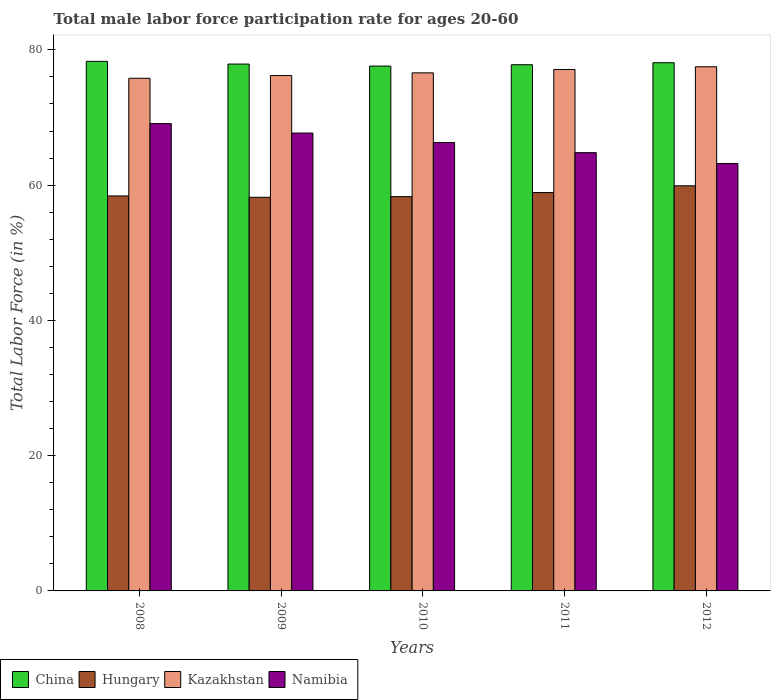How many groups of bars are there?
Your answer should be very brief. 5. Are the number of bars per tick equal to the number of legend labels?
Provide a succinct answer. Yes. How many bars are there on the 1st tick from the left?
Provide a succinct answer. 4. How many bars are there on the 4th tick from the right?
Give a very brief answer. 4. What is the label of the 4th group of bars from the left?
Give a very brief answer. 2011. What is the male labor force participation rate in China in 2011?
Ensure brevity in your answer.  77.8. Across all years, what is the maximum male labor force participation rate in Namibia?
Ensure brevity in your answer.  69.1. Across all years, what is the minimum male labor force participation rate in Namibia?
Ensure brevity in your answer.  63.2. In which year was the male labor force participation rate in Kazakhstan maximum?
Offer a terse response. 2012. In which year was the male labor force participation rate in Hungary minimum?
Offer a terse response. 2009. What is the total male labor force participation rate in China in the graph?
Offer a terse response. 389.7. What is the difference between the male labor force participation rate in Namibia in 2010 and that in 2012?
Provide a short and direct response. 3.1. What is the difference between the male labor force participation rate in China in 2010 and the male labor force participation rate in Kazakhstan in 2009?
Your response must be concise. 1.4. What is the average male labor force participation rate in Hungary per year?
Your answer should be compact. 58.74. In the year 2011, what is the difference between the male labor force participation rate in Kazakhstan and male labor force participation rate in Namibia?
Provide a succinct answer. 12.3. What is the ratio of the male labor force participation rate in Kazakhstan in 2009 to that in 2012?
Your response must be concise. 0.98. Is the male labor force participation rate in Namibia in 2011 less than that in 2012?
Offer a terse response. No. What is the difference between the highest and the second highest male labor force participation rate in Kazakhstan?
Offer a terse response. 0.4. What is the difference between the highest and the lowest male labor force participation rate in Kazakhstan?
Give a very brief answer. 1.7. In how many years, is the male labor force participation rate in Kazakhstan greater than the average male labor force participation rate in Kazakhstan taken over all years?
Your response must be concise. 2. What does the 1st bar from the left in 2010 represents?
Make the answer very short. China. What does the 3rd bar from the right in 2008 represents?
Provide a succinct answer. Hungary. Is it the case that in every year, the sum of the male labor force participation rate in China and male labor force participation rate in Namibia is greater than the male labor force participation rate in Kazakhstan?
Keep it short and to the point. Yes. How many bars are there?
Provide a short and direct response. 20. What is the difference between two consecutive major ticks on the Y-axis?
Give a very brief answer. 20. Are the values on the major ticks of Y-axis written in scientific E-notation?
Offer a very short reply. No. What is the title of the graph?
Your answer should be very brief. Total male labor force participation rate for ages 20-60. What is the Total Labor Force (in %) of China in 2008?
Ensure brevity in your answer.  78.3. What is the Total Labor Force (in %) of Hungary in 2008?
Your answer should be very brief. 58.4. What is the Total Labor Force (in %) of Kazakhstan in 2008?
Your response must be concise. 75.8. What is the Total Labor Force (in %) in Namibia in 2008?
Your answer should be compact. 69.1. What is the Total Labor Force (in %) in China in 2009?
Offer a terse response. 77.9. What is the Total Labor Force (in %) of Hungary in 2009?
Your response must be concise. 58.2. What is the Total Labor Force (in %) of Kazakhstan in 2009?
Offer a terse response. 76.2. What is the Total Labor Force (in %) of Namibia in 2009?
Provide a succinct answer. 67.7. What is the Total Labor Force (in %) of China in 2010?
Ensure brevity in your answer.  77.6. What is the Total Labor Force (in %) of Hungary in 2010?
Give a very brief answer. 58.3. What is the Total Labor Force (in %) of Kazakhstan in 2010?
Make the answer very short. 76.6. What is the Total Labor Force (in %) in Namibia in 2010?
Offer a very short reply. 66.3. What is the Total Labor Force (in %) of China in 2011?
Offer a very short reply. 77.8. What is the Total Labor Force (in %) in Hungary in 2011?
Give a very brief answer. 58.9. What is the Total Labor Force (in %) in Kazakhstan in 2011?
Keep it short and to the point. 77.1. What is the Total Labor Force (in %) in Namibia in 2011?
Keep it short and to the point. 64.8. What is the Total Labor Force (in %) in China in 2012?
Ensure brevity in your answer.  78.1. What is the Total Labor Force (in %) in Hungary in 2012?
Your response must be concise. 59.9. What is the Total Labor Force (in %) in Kazakhstan in 2012?
Ensure brevity in your answer.  77.5. What is the Total Labor Force (in %) of Namibia in 2012?
Provide a succinct answer. 63.2. Across all years, what is the maximum Total Labor Force (in %) of China?
Offer a very short reply. 78.3. Across all years, what is the maximum Total Labor Force (in %) in Hungary?
Offer a terse response. 59.9. Across all years, what is the maximum Total Labor Force (in %) of Kazakhstan?
Provide a succinct answer. 77.5. Across all years, what is the maximum Total Labor Force (in %) in Namibia?
Your answer should be very brief. 69.1. Across all years, what is the minimum Total Labor Force (in %) in China?
Provide a short and direct response. 77.6. Across all years, what is the minimum Total Labor Force (in %) in Hungary?
Make the answer very short. 58.2. Across all years, what is the minimum Total Labor Force (in %) of Kazakhstan?
Provide a short and direct response. 75.8. Across all years, what is the minimum Total Labor Force (in %) of Namibia?
Make the answer very short. 63.2. What is the total Total Labor Force (in %) of China in the graph?
Provide a short and direct response. 389.7. What is the total Total Labor Force (in %) in Hungary in the graph?
Offer a very short reply. 293.7. What is the total Total Labor Force (in %) in Kazakhstan in the graph?
Your answer should be very brief. 383.2. What is the total Total Labor Force (in %) in Namibia in the graph?
Provide a short and direct response. 331.1. What is the difference between the Total Labor Force (in %) in China in 2008 and that in 2009?
Give a very brief answer. 0.4. What is the difference between the Total Labor Force (in %) in Kazakhstan in 2008 and that in 2009?
Give a very brief answer. -0.4. What is the difference between the Total Labor Force (in %) of China in 2008 and that in 2010?
Offer a very short reply. 0.7. What is the difference between the Total Labor Force (in %) of Kazakhstan in 2008 and that in 2010?
Provide a short and direct response. -0.8. What is the difference between the Total Labor Force (in %) of China in 2008 and that in 2011?
Your response must be concise. 0.5. What is the difference between the Total Labor Force (in %) of Hungary in 2008 and that in 2011?
Keep it short and to the point. -0.5. What is the difference between the Total Labor Force (in %) in Kazakhstan in 2008 and that in 2011?
Provide a short and direct response. -1.3. What is the difference between the Total Labor Force (in %) in Hungary in 2008 and that in 2012?
Make the answer very short. -1.5. What is the difference between the Total Labor Force (in %) of Kazakhstan in 2008 and that in 2012?
Keep it short and to the point. -1.7. What is the difference between the Total Labor Force (in %) of China in 2009 and that in 2010?
Your response must be concise. 0.3. What is the difference between the Total Labor Force (in %) in Hungary in 2009 and that in 2010?
Make the answer very short. -0.1. What is the difference between the Total Labor Force (in %) in Kazakhstan in 2009 and that in 2010?
Ensure brevity in your answer.  -0.4. What is the difference between the Total Labor Force (in %) of Namibia in 2009 and that in 2010?
Your answer should be compact. 1.4. What is the difference between the Total Labor Force (in %) of China in 2009 and that in 2011?
Give a very brief answer. 0.1. What is the difference between the Total Labor Force (in %) of Hungary in 2009 and that in 2011?
Provide a short and direct response. -0.7. What is the difference between the Total Labor Force (in %) in Kazakhstan in 2009 and that in 2011?
Your response must be concise. -0.9. What is the difference between the Total Labor Force (in %) in Namibia in 2009 and that in 2011?
Your answer should be very brief. 2.9. What is the difference between the Total Labor Force (in %) of Hungary in 2009 and that in 2012?
Give a very brief answer. -1.7. What is the difference between the Total Labor Force (in %) in Kazakhstan in 2009 and that in 2012?
Keep it short and to the point. -1.3. What is the difference between the Total Labor Force (in %) of China in 2010 and that in 2012?
Offer a terse response. -0.5. What is the difference between the Total Labor Force (in %) in Hungary in 2010 and that in 2012?
Your answer should be compact. -1.6. What is the difference between the Total Labor Force (in %) of Kazakhstan in 2010 and that in 2012?
Provide a succinct answer. -0.9. What is the difference between the Total Labor Force (in %) of Hungary in 2011 and that in 2012?
Offer a very short reply. -1. What is the difference between the Total Labor Force (in %) in Kazakhstan in 2011 and that in 2012?
Your answer should be compact. -0.4. What is the difference between the Total Labor Force (in %) in China in 2008 and the Total Labor Force (in %) in Hungary in 2009?
Your response must be concise. 20.1. What is the difference between the Total Labor Force (in %) of China in 2008 and the Total Labor Force (in %) of Kazakhstan in 2009?
Provide a short and direct response. 2.1. What is the difference between the Total Labor Force (in %) in China in 2008 and the Total Labor Force (in %) in Namibia in 2009?
Ensure brevity in your answer.  10.6. What is the difference between the Total Labor Force (in %) in Hungary in 2008 and the Total Labor Force (in %) in Kazakhstan in 2009?
Ensure brevity in your answer.  -17.8. What is the difference between the Total Labor Force (in %) of Kazakhstan in 2008 and the Total Labor Force (in %) of Namibia in 2009?
Ensure brevity in your answer.  8.1. What is the difference between the Total Labor Force (in %) in Hungary in 2008 and the Total Labor Force (in %) in Kazakhstan in 2010?
Ensure brevity in your answer.  -18.2. What is the difference between the Total Labor Force (in %) of China in 2008 and the Total Labor Force (in %) of Kazakhstan in 2011?
Offer a very short reply. 1.2. What is the difference between the Total Labor Force (in %) of China in 2008 and the Total Labor Force (in %) of Namibia in 2011?
Keep it short and to the point. 13.5. What is the difference between the Total Labor Force (in %) in Hungary in 2008 and the Total Labor Force (in %) in Kazakhstan in 2011?
Keep it short and to the point. -18.7. What is the difference between the Total Labor Force (in %) in China in 2008 and the Total Labor Force (in %) in Hungary in 2012?
Keep it short and to the point. 18.4. What is the difference between the Total Labor Force (in %) of China in 2008 and the Total Labor Force (in %) of Kazakhstan in 2012?
Your answer should be very brief. 0.8. What is the difference between the Total Labor Force (in %) in Hungary in 2008 and the Total Labor Force (in %) in Kazakhstan in 2012?
Offer a very short reply. -19.1. What is the difference between the Total Labor Force (in %) of Kazakhstan in 2008 and the Total Labor Force (in %) of Namibia in 2012?
Keep it short and to the point. 12.6. What is the difference between the Total Labor Force (in %) of China in 2009 and the Total Labor Force (in %) of Hungary in 2010?
Keep it short and to the point. 19.6. What is the difference between the Total Labor Force (in %) in China in 2009 and the Total Labor Force (in %) in Kazakhstan in 2010?
Your answer should be very brief. 1.3. What is the difference between the Total Labor Force (in %) in Hungary in 2009 and the Total Labor Force (in %) in Kazakhstan in 2010?
Your response must be concise. -18.4. What is the difference between the Total Labor Force (in %) of Hungary in 2009 and the Total Labor Force (in %) of Namibia in 2010?
Offer a very short reply. -8.1. What is the difference between the Total Labor Force (in %) in Kazakhstan in 2009 and the Total Labor Force (in %) in Namibia in 2010?
Your answer should be very brief. 9.9. What is the difference between the Total Labor Force (in %) in China in 2009 and the Total Labor Force (in %) in Kazakhstan in 2011?
Ensure brevity in your answer.  0.8. What is the difference between the Total Labor Force (in %) in China in 2009 and the Total Labor Force (in %) in Namibia in 2011?
Provide a short and direct response. 13.1. What is the difference between the Total Labor Force (in %) of Hungary in 2009 and the Total Labor Force (in %) of Kazakhstan in 2011?
Your answer should be compact. -18.9. What is the difference between the Total Labor Force (in %) in Kazakhstan in 2009 and the Total Labor Force (in %) in Namibia in 2011?
Make the answer very short. 11.4. What is the difference between the Total Labor Force (in %) in Hungary in 2009 and the Total Labor Force (in %) in Kazakhstan in 2012?
Keep it short and to the point. -19.3. What is the difference between the Total Labor Force (in %) of China in 2010 and the Total Labor Force (in %) of Kazakhstan in 2011?
Your answer should be very brief. 0.5. What is the difference between the Total Labor Force (in %) in Hungary in 2010 and the Total Labor Force (in %) in Kazakhstan in 2011?
Your answer should be very brief. -18.8. What is the difference between the Total Labor Force (in %) in China in 2010 and the Total Labor Force (in %) in Kazakhstan in 2012?
Provide a succinct answer. 0.1. What is the difference between the Total Labor Force (in %) of Hungary in 2010 and the Total Labor Force (in %) of Kazakhstan in 2012?
Your response must be concise. -19.2. What is the difference between the Total Labor Force (in %) of Hungary in 2010 and the Total Labor Force (in %) of Namibia in 2012?
Ensure brevity in your answer.  -4.9. What is the difference between the Total Labor Force (in %) in Kazakhstan in 2010 and the Total Labor Force (in %) in Namibia in 2012?
Give a very brief answer. 13.4. What is the difference between the Total Labor Force (in %) in China in 2011 and the Total Labor Force (in %) in Kazakhstan in 2012?
Your answer should be compact. 0.3. What is the difference between the Total Labor Force (in %) of Hungary in 2011 and the Total Labor Force (in %) of Kazakhstan in 2012?
Your answer should be very brief. -18.6. What is the difference between the Total Labor Force (in %) in Hungary in 2011 and the Total Labor Force (in %) in Namibia in 2012?
Your answer should be very brief. -4.3. What is the average Total Labor Force (in %) of China per year?
Ensure brevity in your answer.  77.94. What is the average Total Labor Force (in %) in Hungary per year?
Ensure brevity in your answer.  58.74. What is the average Total Labor Force (in %) of Kazakhstan per year?
Your response must be concise. 76.64. What is the average Total Labor Force (in %) of Namibia per year?
Your answer should be very brief. 66.22. In the year 2008, what is the difference between the Total Labor Force (in %) of China and Total Labor Force (in %) of Hungary?
Offer a very short reply. 19.9. In the year 2008, what is the difference between the Total Labor Force (in %) of China and Total Labor Force (in %) of Namibia?
Provide a succinct answer. 9.2. In the year 2008, what is the difference between the Total Labor Force (in %) in Hungary and Total Labor Force (in %) in Kazakhstan?
Offer a terse response. -17.4. In the year 2008, what is the difference between the Total Labor Force (in %) in Hungary and Total Labor Force (in %) in Namibia?
Offer a very short reply. -10.7. In the year 2009, what is the difference between the Total Labor Force (in %) of China and Total Labor Force (in %) of Kazakhstan?
Offer a very short reply. 1.7. In the year 2009, what is the difference between the Total Labor Force (in %) in Hungary and Total Labor Force (in %) in Namibia?
Ensure brevity in your answer.  -9.5. In the year 2009, what is the difference between the Total Labor Force (in %) of Kazakhstan and Total Labor Force (in %) of Namibia?
Your answer should be very brief. 8.5. In the year 2010, what is the difference between the Total Labor Force (in %) of China and Total Labor Force (in %) of Hungary?
Ensure brevity in your answer.  19.3. In the year 2010, what is the difference between the Total Labor Force (in %) in China and Total Labor Force (in %) in Namibia?
Your answer should be very brief. 11.3. In the year 2010, what is the difference between the Total Labor Force (in %) in Hungary and Total Labor Force (in %) in Kazakhstan?
Provide a short and direct response. -18.3. In the year 2010, what is the difference between the Total Labor Force (in %) in Hungary and Total Labor Force (in %) in Namibia?
Make the answer very short. -8. In the year 2010, what is the difference between the Total Labor Force (in %) of Kazakhstan and Total Labor Force (in %) of Namibia?
Provide a succinct answer. 10.3. In the year 2011, what is the difference between the Total Labor Force (in %) of China and Total Labor Force (in %) of Hungary?
Your answer should be compact. 18.9. In the year 2011, what is the difference between the Total Labor Force (in %) in China and Total Labor Force (in %) in Kazakhstan?
Provide a short and direct response. 0.7. In the year 2011, what is the difference between the Total Labor Force (in %) in Hungary and Total Labor Force (in %) in Kazakhstan?
Your answer should be compact. -18.2. In the year 2011, what is the difference between the Total Labor Force (in %) of Kazakhstan and Total Labor Force (in %) of Namibia?
Your response must be concise. 12.3. In the year 2012, what is the difference between the Total Labor Force (in %) in China and Total Labor Force (in %) in Hungary?
Offer a very short reply. 18.2. In the year 2012, what is the difference between the Total Labor Force (in %) of China and Total Labor Force (in %) of Namibia?
Ensure brevity in your answer.  14.9. In the year 2012, what is the difference between the Total Labor Force (in %) of Hungary and Total Labor Force (in %) of Kazakhstan?
Offer a very short reply. -17.6. In the year 2012, what is the difference between the Total Labor Force (in %) in Hungary and Total Labor Force (in %) in Namibia?
Provide a short and direct response. -3.3. What is the ratio of the Total Labor Force (in %) of China in 2008 to that in 2009?
Your answer should be compact. 1.01. What is the ratio of the Total Labor Force (in %) in Kazakhstan in 2008 to that in 2009?
Your response must be concise. 0.99. What is the ratio of the Total Labor Force (in %) of Namibia in 2008 to that in 2009?
Keep it short and to the point. 1.02. What is the ratio of the Total Labor Force (in %) of Kazakhstan in 2008 to that in 2010?
Make the answer very short. 0.99. What is the ratio of the Total Labor Force (in %) in Namibia in 2008 to that in 2010?
Provide a succinct answer. 1.04. What is the ratio of the Total Labor Force (in %) in China in 2008 to that in 2011?
Give a very brief answer. 1.01. What is the ratio of the Total Labor Force (in %) of Hungary in 2008 to that in 2011?
Provide a succinct answer. 0.99. What is the ratio of the Total Labor Force (in %) in Kazakhstan in 2008 to that in 2011?
Give a very brief answer. 0.98. What is the ratio of the Total Labor Force (in %) in Namibia in 2008 to that in 2011?
Provide a short and direct response. 1.07. What is the ratio of the Total Labor Force (in %) of China in 2008 to that in 2012?
Provide a short and direct response. 1. What is the ratio of the Total Labor Force (in %) of Kazakhstan in 2008 to that in 2012?
Ensure brevity in your answer.  0.98. What is the ratio of the Total Labor Force (in %) in Namibia in 2008 to that in 2012?
Make the answer very short. 1.09. What is the ratio of the Total Labor Force (in %) in Hungary in 2009 to that in 2010?
Keep it short and to the point. 1. What is the ratio of the Total Labor Force (in %) of Namibia in 2009 to that in 2010?
Provide a succinct answer. 1.02. What is the ratio of the Total Labor Force (in %) of China in 2009 to that in 2011?
Your answer should be very brief. 1. What is the ratio of the Total Labor Force (in %) in Kazakhstan in 2009 to that in 2011?
Your answer should be very brief. 0.99. What is the ratio of the Total Labor Force (in %) in Namibia in 2009 to that in 2011?
Your answer should be very brief. 1.04. What is the ratio of the Total Labor Force (in %) in China in 2009 to that in 2012?
Give a very brief answer. 1. What is the ratio of the Total Labor Force (in %) in Hungary in 2009 to that in 2012?
Keep it short and to the point. 0.97. What is the ratio of the Total Labor Force (in %) of Kazakhstan in 2009 to that in 2012?
Give a very brief answer. 0.98. What is the ratio of the Total Labor Force (in %) in Namibia in 2009 to that in 2012?
Your answer should be very brief. 1.07. What is the ratio of the Total Labor Force (in %) in China in 2010 to that in 2011?
Offer a terse response. 1. What is the ratio of the Total Labor Force (in %) of Namibia in 2010 to that in 2011?
Offer a terse response. 1.02. What is the ratio of the Total Labor Force (in %) in Hungary in 2010 to that in 2012?
Provide a short and direct response. 0.97. What is the ratio of the Total Labor Force (in %) of Kazakhstan in 2010 to that in 2012?
Provide a succinct answer. 0.99. What is the ratio of the Total Labor Force (in %) in Namibia in 2010 to that in 2012?
Ensure brevity in your answer.  1.05. What is the ratio of the Total Labor Force (in %) in Hungary in 2011 to that in 2012?
Offer a terse response. 0.98. What is the ratio of the Total Labor Force (in %) in Namibia in 2011 to that in 2012?
Make the answer very short. 1.03. What is the difference between the highest and the second highest Total Labor Force (in %) of Hungary?
Offer a very short reply. 1. What is the difference between the highest and the second highest Total Labor Force (in %) of Kazakhstan?
Your response must be concise. 0.4. What is the difference between the highest and the second highest Total Labor Force (in %) of Namibia?
Provide a short and direct response. 1.4. What is the difference between the highest and the lowest Total Labor Force (in %) of China?
Your response must be concise. 0.7. What is the difference between the highest and the lowest Total Labor Force (in %) of Hungary?
Give a very brief answer. 1.7. What is the difference between the highest and the lowest Total Labor Force (in %) in Kazakhstan?
Keep it short and to the point. 1.7. 